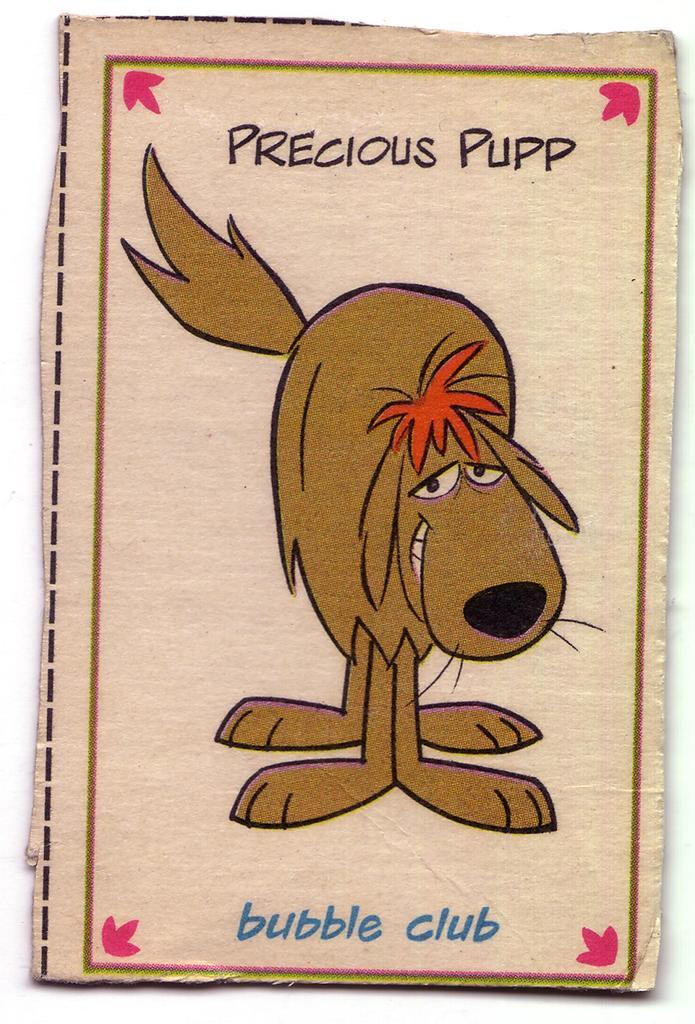What type of content is present in the image? The image contains a cartoon. What type of protest is depicted in the image? There is no protest present in the image; it contains a cartoon. 